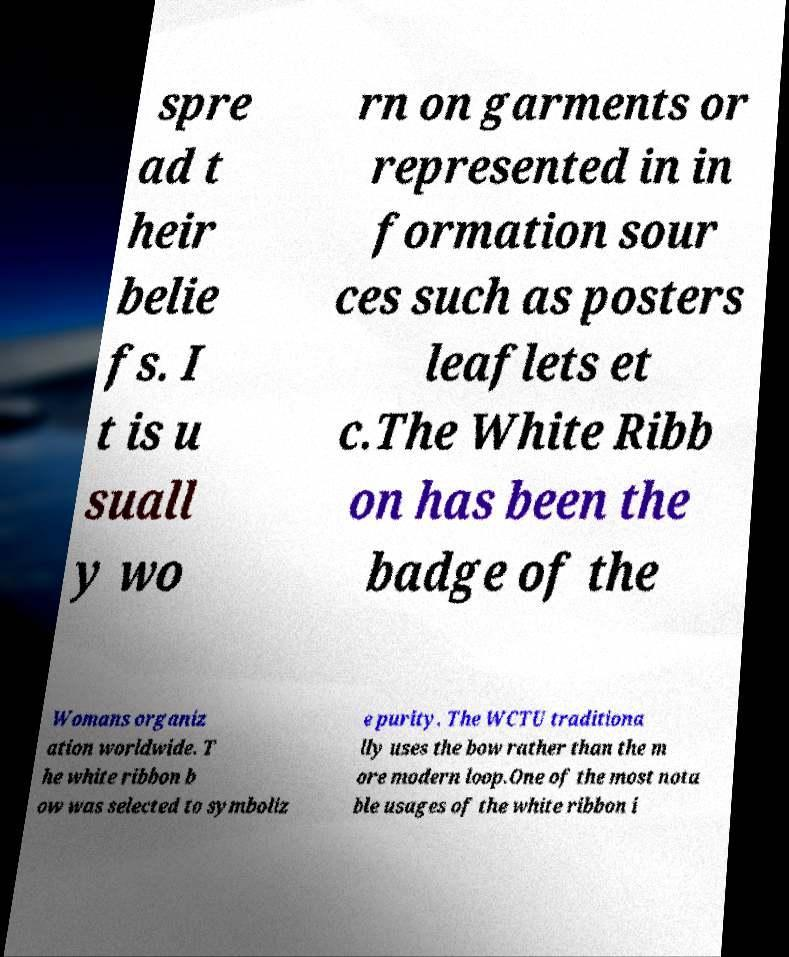Can you accurately transcribe the text from the provided image for me? spre ad t heir belie fs. I t is u suall y wo rn on garments or represented in in formation sour ces such as posters leaflets et c.The White Ribb on has been the badge of the Womans organiz ation worldwide. T he white ribbon b ow was selected to symboliz e purity. The WCTU traditiona lly uses the bow rather than the m ore modern loop.One of the most nota ble usages of the white ribbon i 